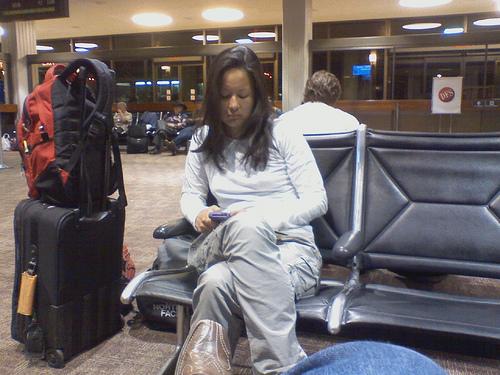How many bags does she have?
Concise answer only. 2. Is the woman waiting for her flight to be announced?
Short answer required. Yes. Is this woman looking at her phone?
Keep it brief. Yes. 